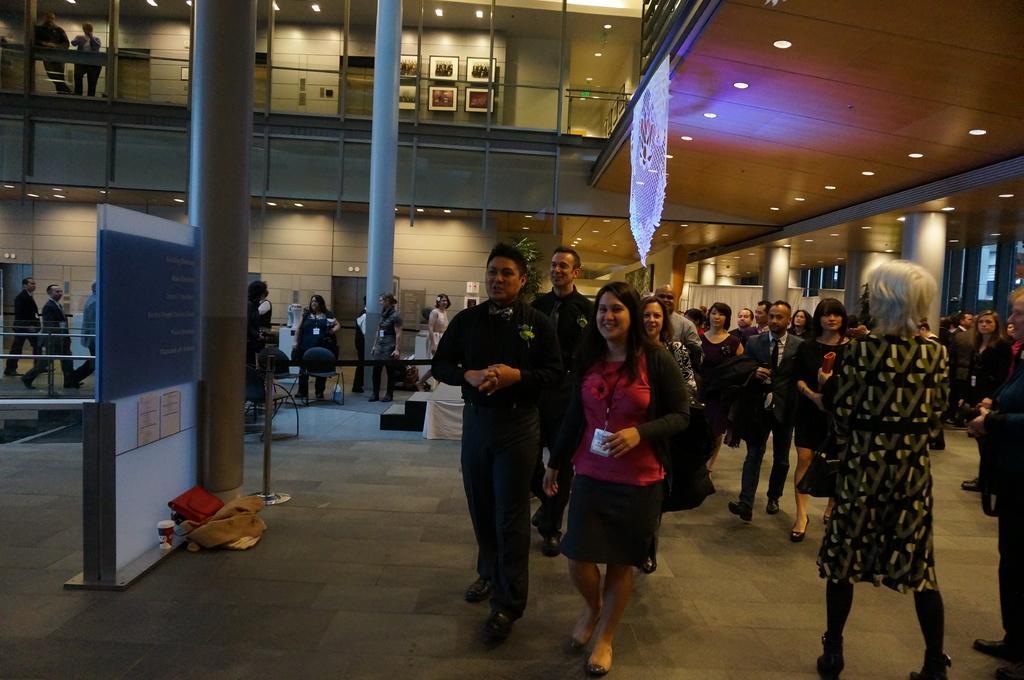Could you give a brief overview of what you see in this image? In this image I can see group of people, some are standing and some are walking. In front the person is wearing red and black color dress. In the background I can see few lights, pillars and I can see few frames attached to the wall. 